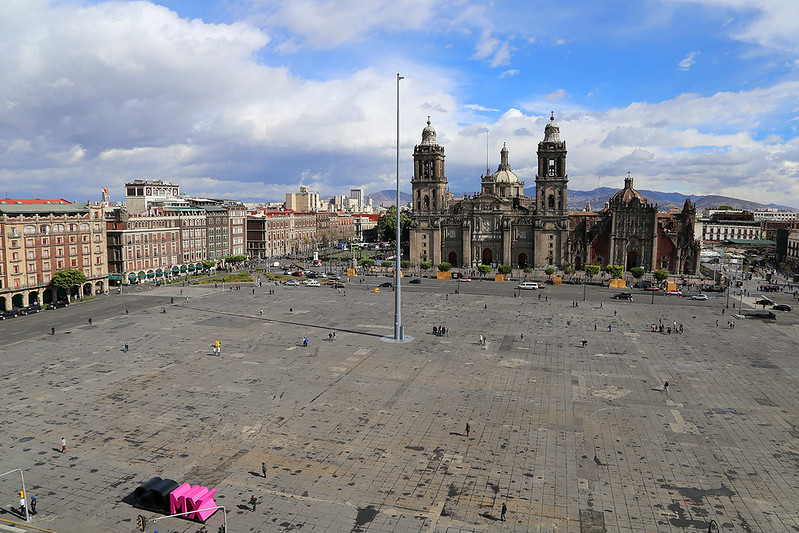If you could visit just one spot in this image, which would it be and why? I would choose to visit the Metropolitan Cathedral. It stands out not only for its architectural grandeur but also for its historical and cultural significance. The cathedral has been a witness to centuries of history and has withstood earthquakes, protests, and the passage of time, making it a symbol of resilience. Exploring its stunning interiors, intricate altars, and valuable artworks, while reflecting on the history it embodies, would be an unforgettable experience. 